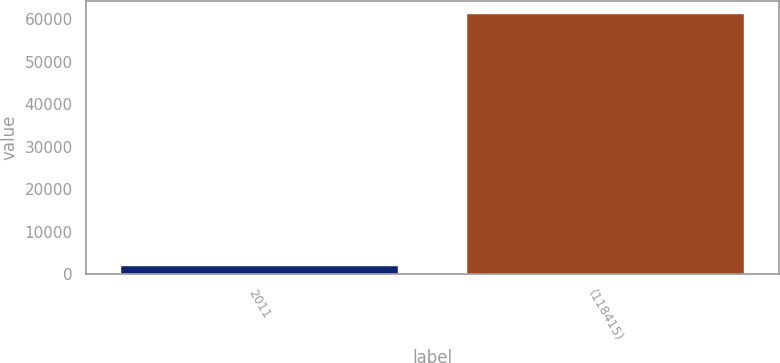Convert chart to OTSL. <chart><loc_0><loc_0><loc_500><loc_500><bar_chart><fcel>2011<fcel>(118415)<nl><fcel>2008<fcel>61236<nl></chart> 